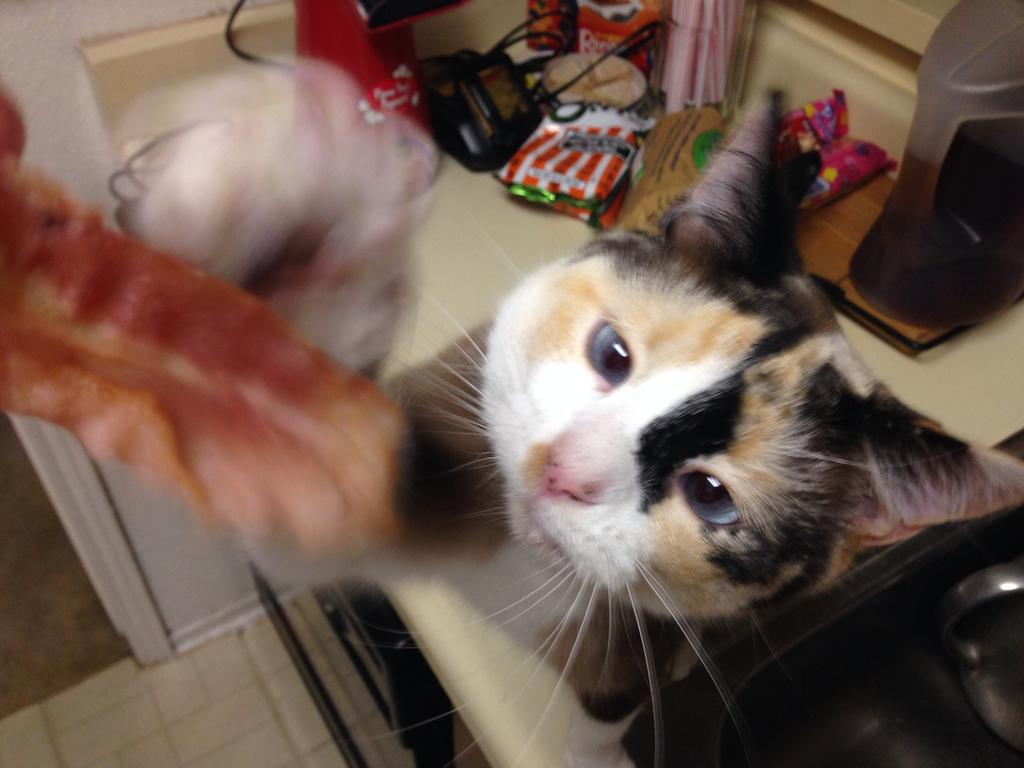What is the main subject in the center of the image? There is a cat in the center of the image. What can be seen in the background of the image? There are covers and cloth in the background of the image. What is on the floor in the background of the image? There is a mat on the floor in the background of the image. What type of food is the cat eating in the image? There is no food present in the image; the cat is not eating anything. Can you describe the beetle that is crawling on the cat's back in the image? There is no beetle present in the image; the cat is alone in the image. 